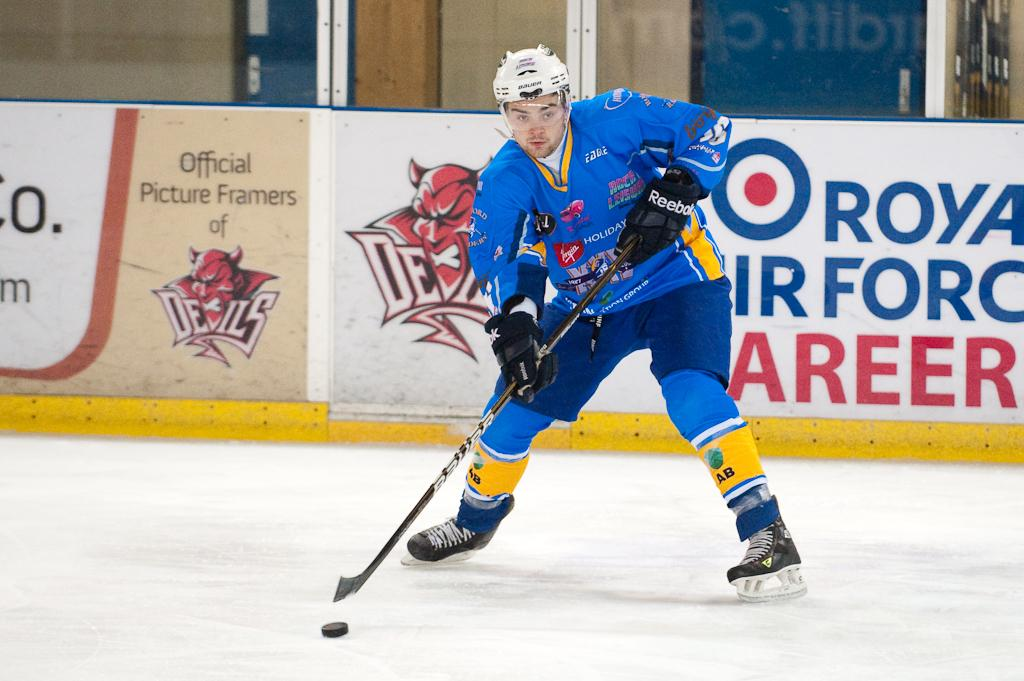<image>
Provide a brief description of the given image. A hockey player has the puck with the logo of the devils behind him. 